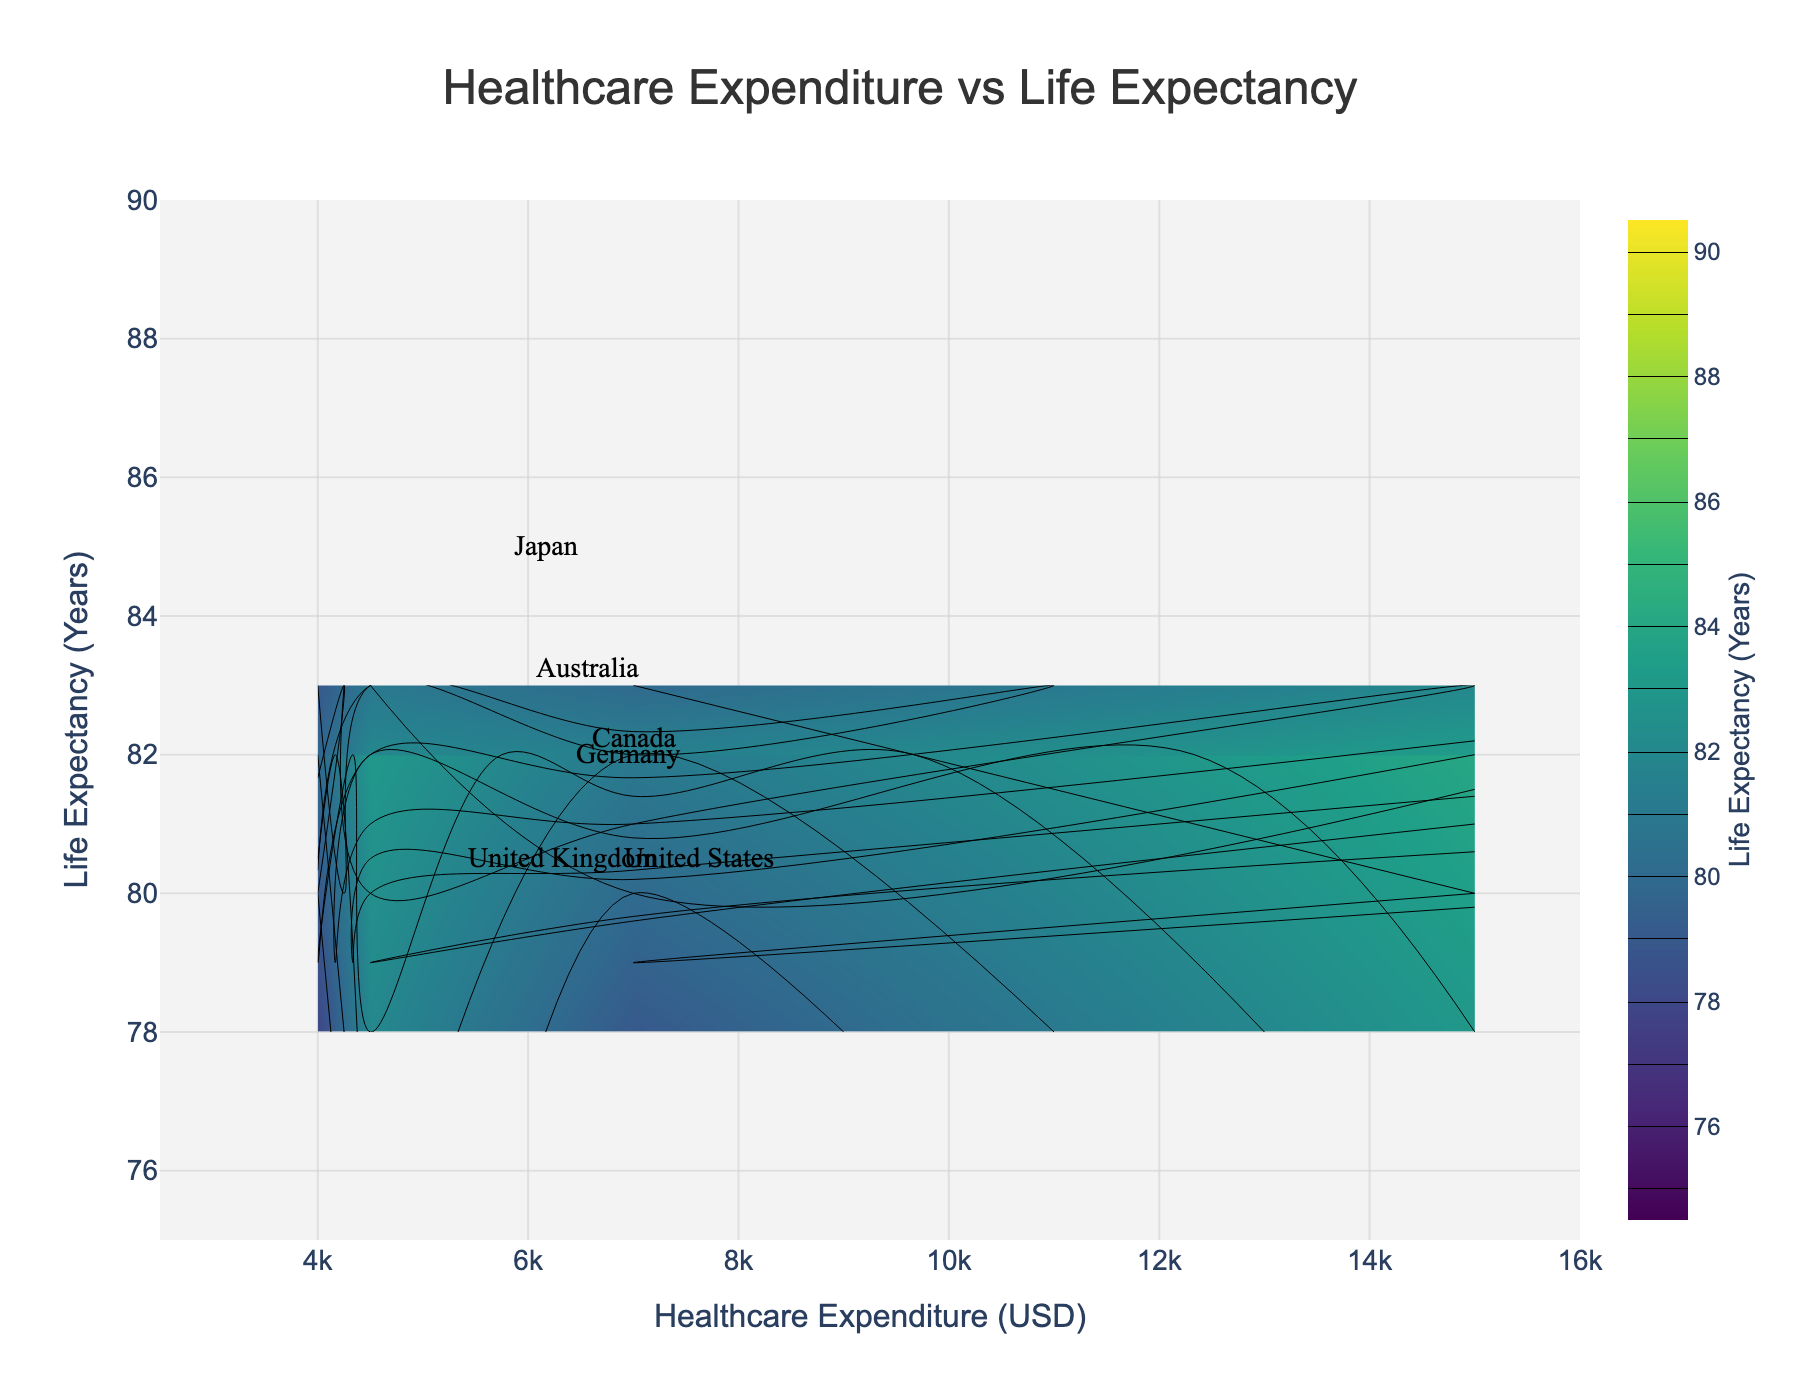what's the title of this figure? The title is located at the top of the figure, typically centered to draw attention. Here, the title reads "Healthcare Expenditure vs Life Expectancy".
Answer: Healthcare Expenditure vs Life Expectancy what is the range of the x-axis in this figure? The x-axis represents Healthcare Expenditure in USD, and its range is depicted on the axis itself. In this plot, it spans from 2500 to 16000 USD.
Answer: 2500 to 16000 USD which country shows the highest average healthcare expenditure for the '65+' age group? To determine this, you look for the highest value on the x-axis, within the data points labeled or annotated for countries. The highest expenditure for '65+' is 15000 USD, which is associated with the United States.
Answer: United States what is the life expectancy range visualized by the contours? The contour lines and the color bar provide the range of life expectancy values. Here, contours start at 75 years and end at 90 years.
Answer: 75 to 90 years how does the life expectancy of Japan compare to the United States for the '25-64' age group? Locate the specific data points for both countries in the '25-64' age group. Japan has a life expectancy of 86 years, whereas the United States stands at 79 years. Thus, Japan has a higher life expectancy.
Answer: Japan has a higher life expectancy by 7 years what is the average healthcare expenditure for '15-24' age group across all countries? Sum up the healthcare expenditures for '15-24' for all countries and divide by the number of countries. (4500 + 4000 + 3700 + 3300 + 4200 + 3900) / 6 = 3933.33 USD
Answer: 3933.33 USD which age group has the lowest life expectancy in the United Kingdom? By checking the life expectancy figures for various age groups in the United Kingdom, the '0-14' group has the lowest at 79 years.
Answer: 0-14 which country has the narrowest range in healthcare expenditure across all its age groups, excluding the lowest and highest values? Calculate the range within the second and third quartiles for each country. Germany's expenditure ranges from 4000 to 6300 USD, giving a narrow range of 2300 USD which appears to be the narrowest.
Answer: Germany how does the life expectancy pattern shift across age groups in Australia as healthcare expenditure increases? Observing Australia's annotated data points across age groups, life expectancy increases from 81 ('0-14'), 83 ('15-24'), 84 ('25-64'), to 85 ('65+'). As healthcare expenditure increases, so does life expectancy.
Answer: Increases evenly which country demonstrates the least incremental increase in healthcare expenditure from '25-64' to '65+' age group? By evaluating the increase in healthcare costs from '25-64' to '65+', Japan increases from 5800 to 12000 USD, an increase of 6200 USD, being the least incremental compared to other countries.
Answer: Japan 